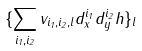<formula> <loc_0><loc_0><loc_500><loc_500>\{ \sum _ { i _ { 1 } , i _ { 2 } } v _ { i _ { 1 } , i _ { 2 } , l } d _ { x } ^ { i _ { 1 } } d _ { y } ^ { i _ { 2 } } h \} _ { l }</formula> 